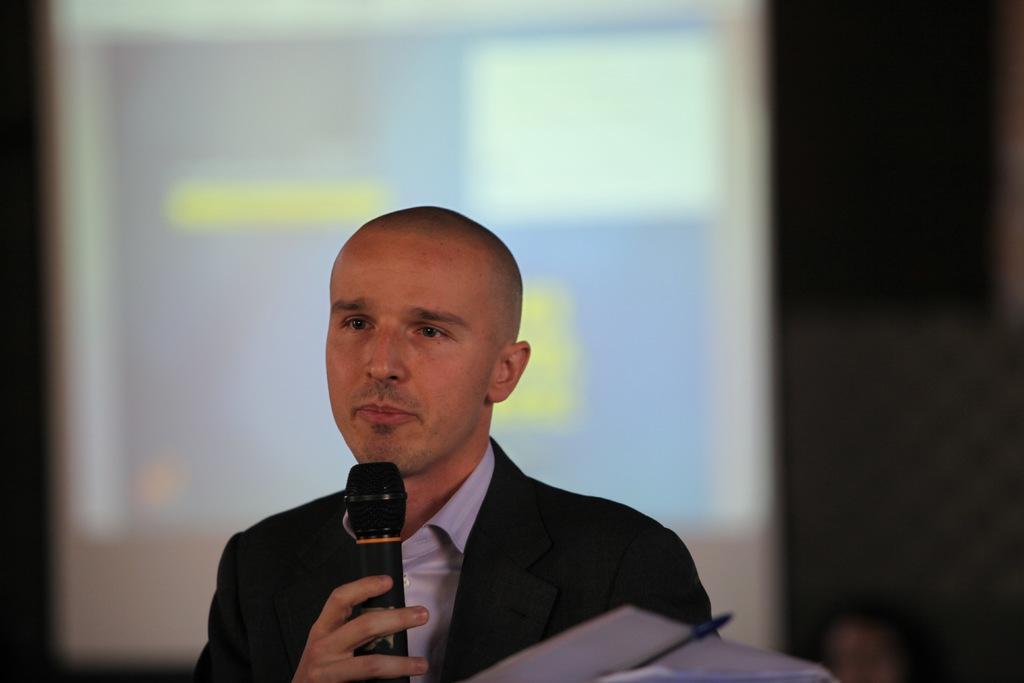Describe this image in one or two sentences. This picture shows a man standing and he is holding a microphone in his hand and we see papers with a pen. He wore a black coat. 